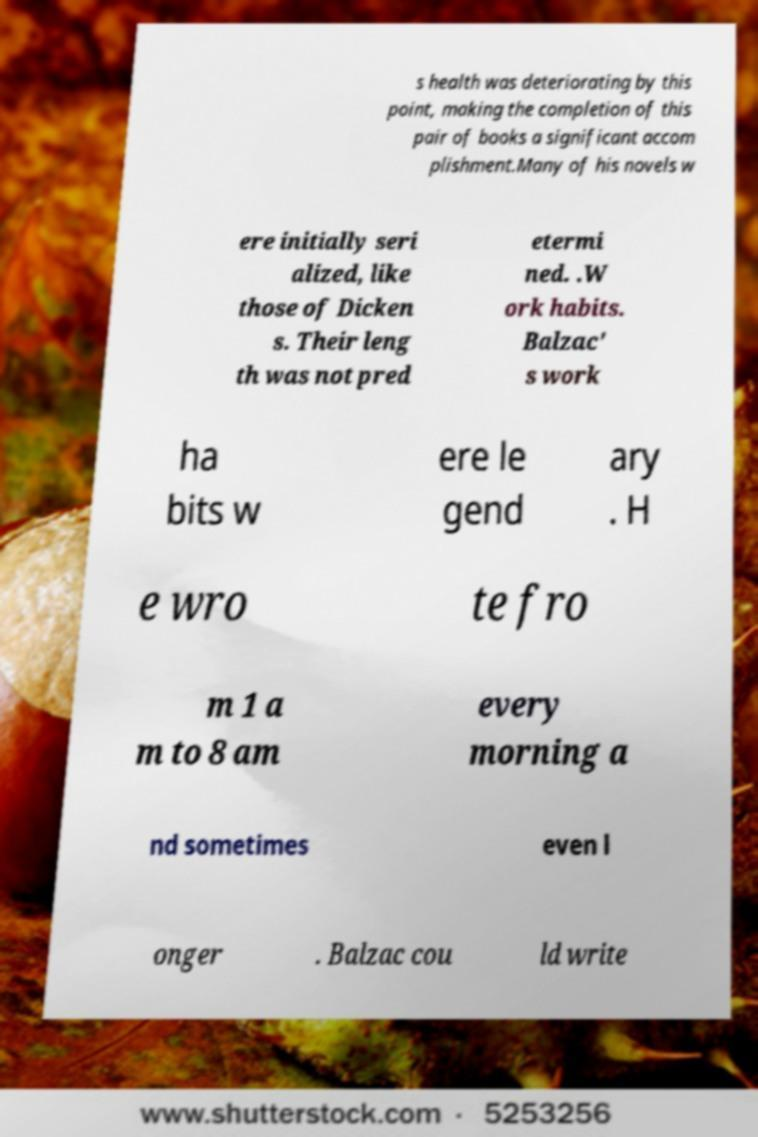I need the written content from this picture converted into text. Can you do that? s health was deteriorating by this point, making the completion of this pair of books a significant accom plishment.Many of his novels w ere initially seri alized, like those of Dicken s. Their leng th was not pred etermi ned. .W ork habits. Balzac' s work ha bits w ere le gend ary . H e wro te fro m 1 a m to 8 am every morning a nd sometimes even l onger . Balzac cou ld write 